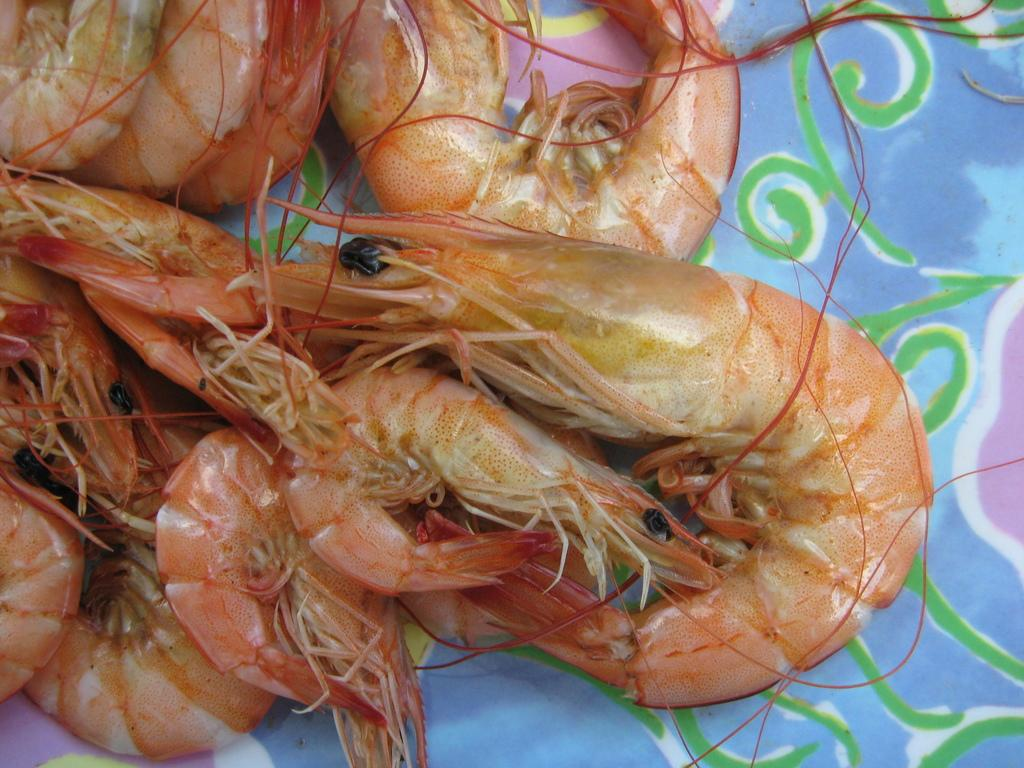What type of seafood is present in the image? There are prawns in the image. Where are the prawns located? The prawns are placed on a surface. In which direction are the prawns' eyes looking in the image? Prawns do not have eyes, so this question cannot be answered based on the image. 